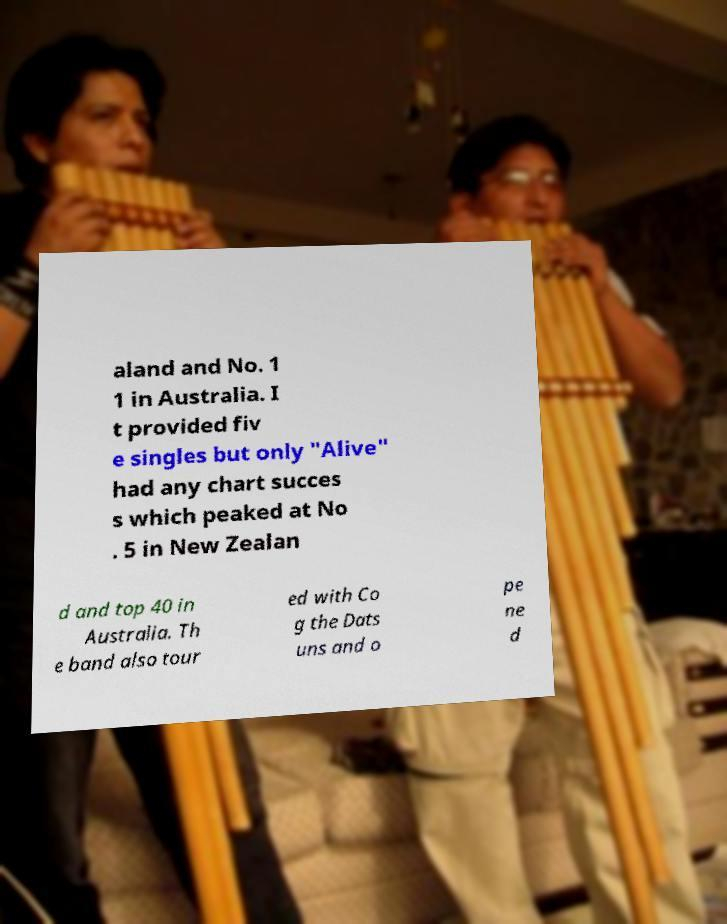Could you assist in decoding the text presented in this image and type it out clearly? aland and No. 1 1 in Australia. I t provided fiv e singles but only "Alive" had any chart succes s which peaked at No . 5 in New Zealan d and top 40 in Australia. Th e band also tour ed with Co g the Dats uns and o pe ne d 